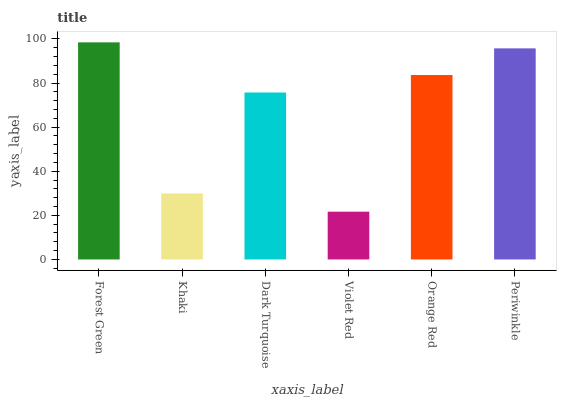Is Khaki the minimum?
Answer yes or no. No. Is Khaki the maximum?
Answer yes or no. No. Is Forest Green greater than Khaki?
Answer yes or no. Yes. Is Khaki less than Forest Green?
Answer yes or no. Yes. Is Khaki greater than Forest Green?
Answer yes or no. No. Is Forest Green less than Khaki?
Answer yes or no. No. Is Orange Red the high median?
Answer yes or no. Yes. Is Dark Turquoise the low median?
Answer yes or no. Yes. Is Forest Green the high median?
Answer yes or no. No. Is Periwinkle the low median?
Answer yes or no. No. 